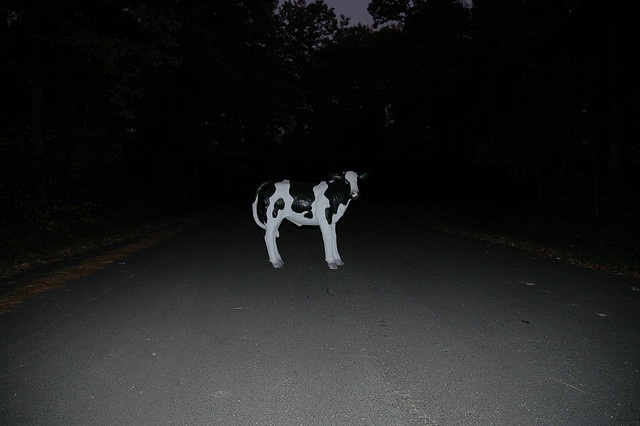Describe the objects in this image and their specific colors. I can see a cow in black, darkgray, and gray tones in this image. 